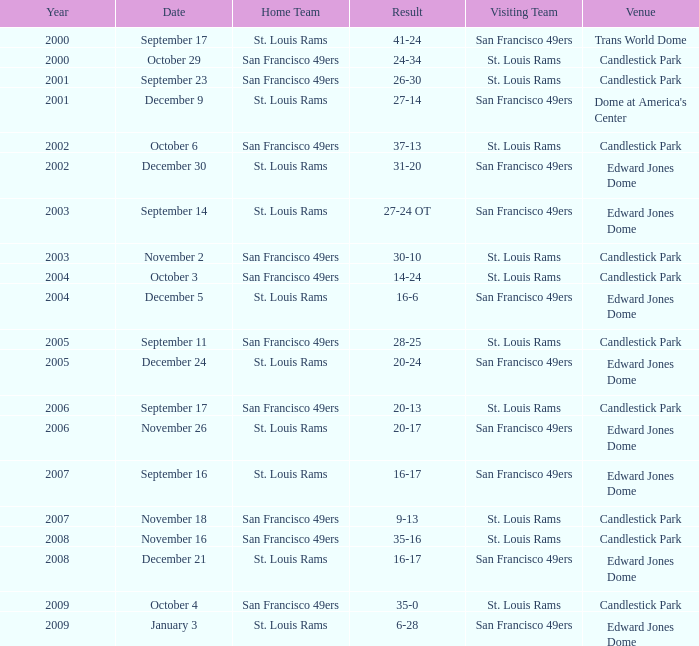What was the place on november 26? Edward Jones Dome. Parse the table in full. {'header': ['Year', 'Date', 'Home Team', 'Result', 'Visiting Team', 'Venue'], 'rows': [['2000', 'September 17', 'St. Louis Rams', '41-24', 'San Francisco 49ers', 'Trans World Dome'], ['2000', 'October 29', 'San Francisco 49ers', '24-34', 'St. Louis Rams', 'Candlestick Park'], ['2001', 'September 23', 'San Francisco 49ers', '26-30', 'St. Louis Rams', 'Candlestick Park'], ['2001', 'December 9', 'St. Louis Rams', '27-14', 'San Francisco 49ers', "Dome at America's Center"], ['2002', 'October 6', 'San Francisco 49ers', '37-13', 'St. Louis Rams', 'Candlestick Park'], ['2002', 'December 30', 'St. Louis Rams', '31-20', 'San Francisco 49ers', 'Edward Jones Dome'], ['2003', 'September 14', 'St. Louis Rams', '27-24 OT', 'San Francisco 49ers', 'Edward Jones Dome'], ['2003', 'November 2', 'San Francisco 49ers', '30-10', 'St. Louis Rams', 'Candlestick Park'], ['2004', 'October 3', 'San Francisco 49ers', '14-24', 'St. Louis Rams', 'Candlestick Park'], ['2004', 'December 5', 'St. Louis Rams', '16-6', 'San Francisco 49ers', 'Edward Jones Dome'], ['2005', 'September 11', 'San Francisco 49ers', '28-25', 'St. Louis Rams', 'Candlestick Park'], ['2005', 'December 24', 'St. Louis Rams', '20-24', 'San Francisco 49ers', 'Edward Jones Dome'], ['2006', 'September 17', 'San Francisco 49ers', '20-13', 'St. Louis Rams', 'Candlestick Park'], ['2006', 'November 26', 'St. Louis Rams', '20-17', 'San Francisco 49ers', 'Edward Jones Dome'], ['2007', 'September 16', 'St. Louis Rams', '16-17', 'San Francisco 49ers', 'Edward Jones Dome'], ['2007', 'November 18', 'San Francisco 49ers', '9-13', 'St. Louis Rams', 'Candlestick Park'], ['2008', 'November 16', 'San Francisco 49ers', '35-16', 'St. Louis Rams', 'Candlestick Park'], ['2008', 'December 21', 'St. Louis Rams', '16-17', 'San Francisco 49ers', 'Edward Jones Dome'], ['2009', 'October 4', 'San Francisco 49ers', '35-0', 'St. Louis Rams', 'Candlestick Park'], ['2009', 'January 3', 'St. Louis Rams', '6-28', 'San Francisco 49ers', 'Edward Jones Dome']]} 